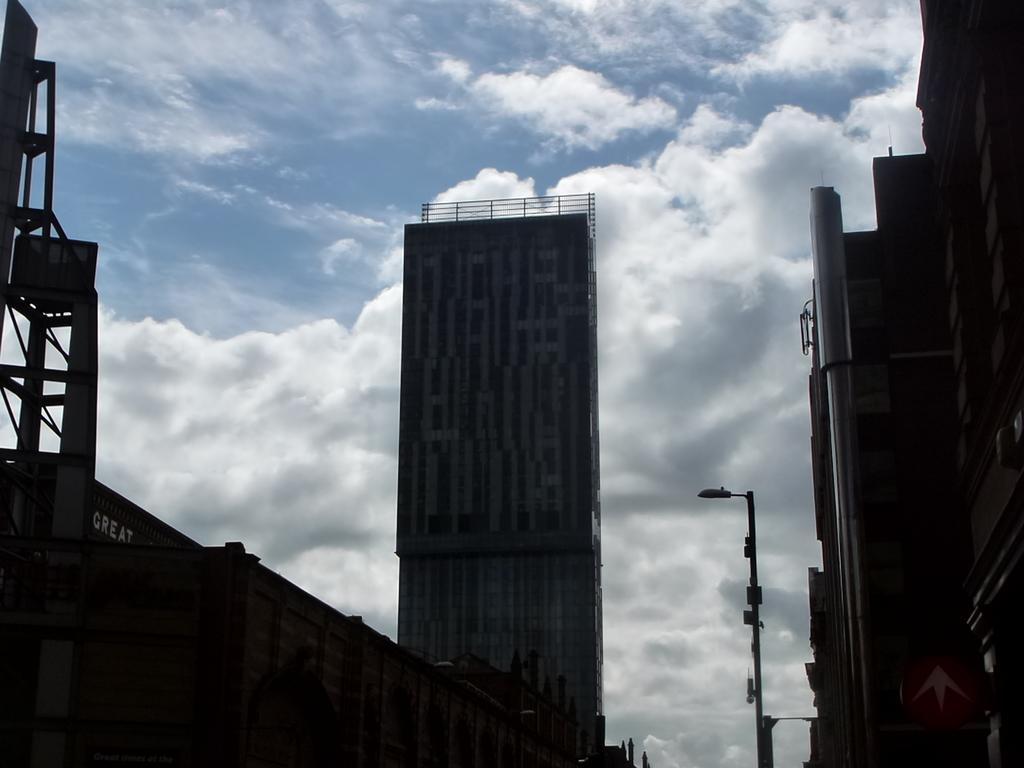In one or two sentences, can you explain what this image depicts? This picture is clicked outside. In the center we can see the buildings and we can see a street light attached to the pole and there are some metal rods. In the background there is a sky which is full of clouds. 